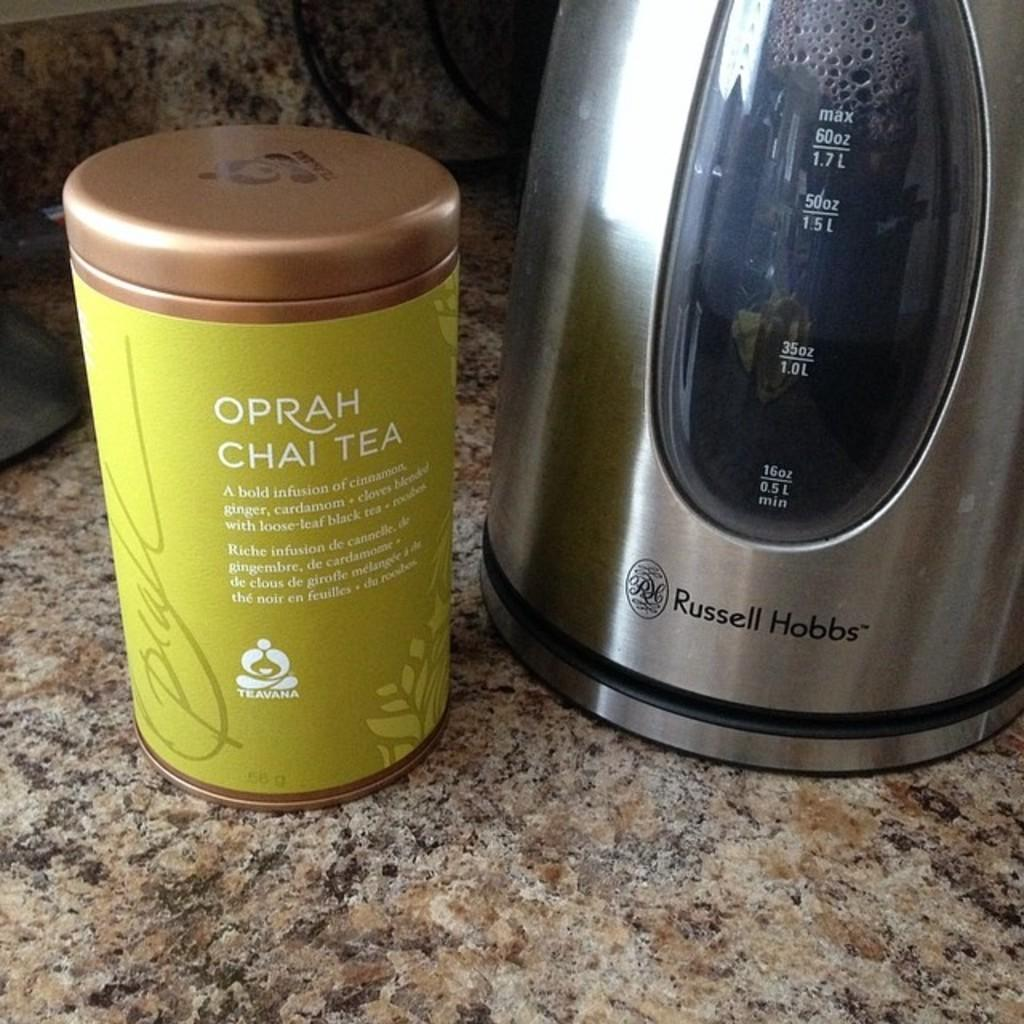<image>
Offer a succinct explanation of the picture presented. A canister of Oprah Chai Tea standing on a marble table besides a Russell Hobbs tea maker. 